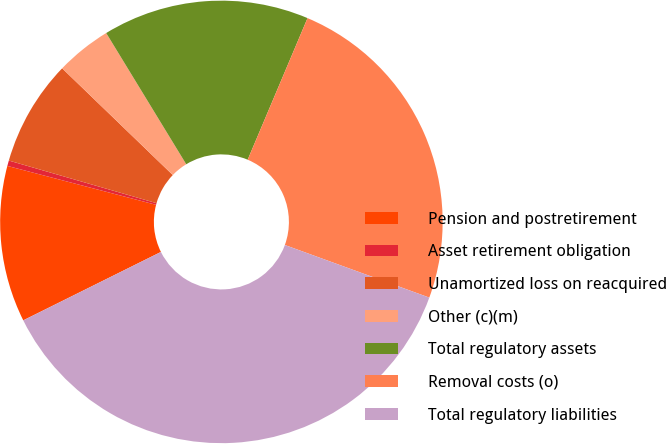Convert chart. <chart><loc_0><loc_0><loc_500><loc_500><pie_chart><fcel>Pension and postretirement<fcel>Asset retirement obligation<fcel>Unamortized loss on reacquired<fcel>Other (c)(m)<fcel>Total regulatory assets<fcel>Removal costs (o)<fcel>Total regulatory liabilities<nl><fcel>11.41%<fcel>0.4%<fcel>7.74%<fcel>4.07%<fcel>15.08%<fcel>24.19%<fcel>37.1%<nl></chart> 